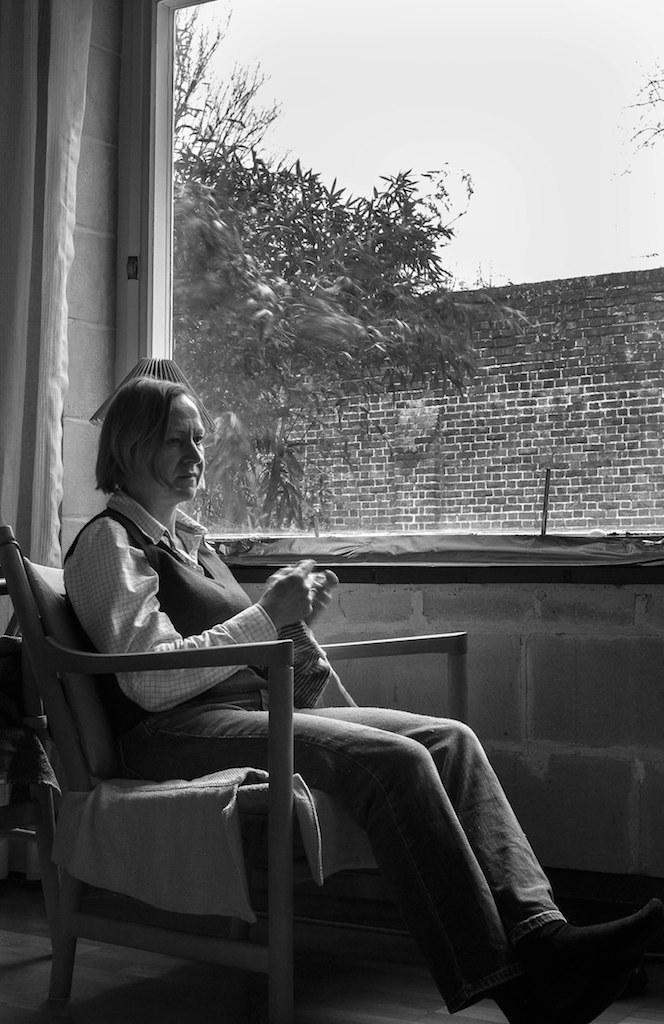In one or two sentences, can you explain what this image depicts? There is a woman sitting on a chair. Here we can see a glass window. Here we can see a tree and this is a wall. 